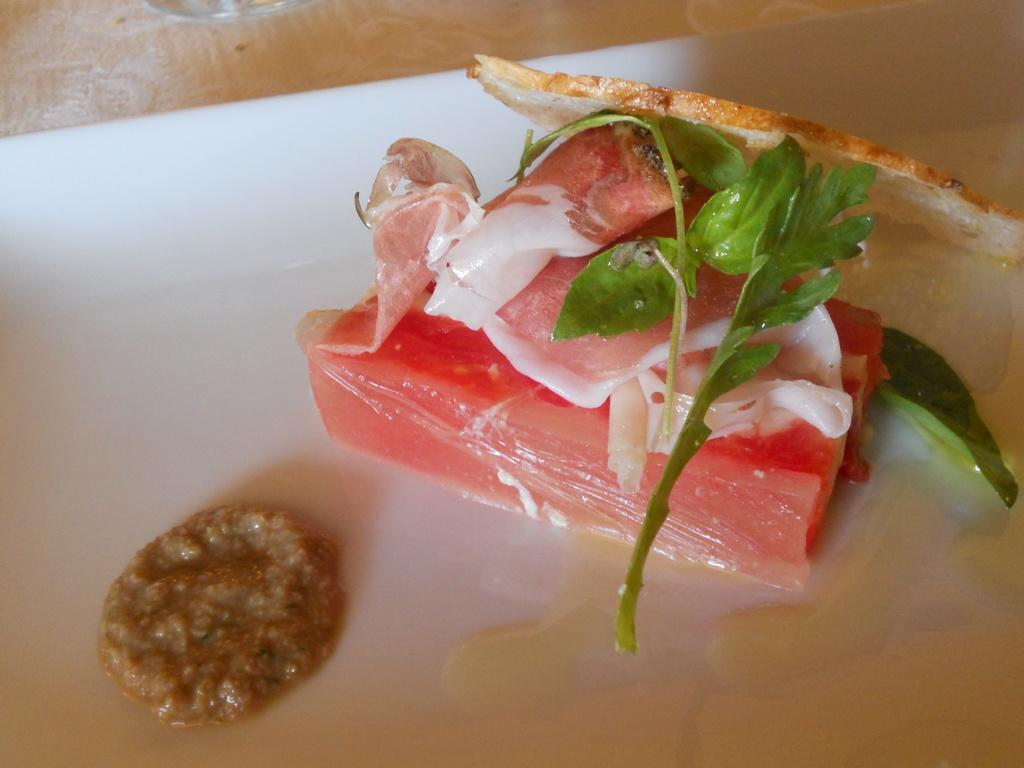What type of items can be seen in the image? There are food items in the image. How are the food items arranged or presented? The food items are on a white plate. What is the color of the plate? The plate is white. Is there any other object supporting the plate in the image? Yes, the plate is on an object. What day of the week is depicted in the image? There is no indication of a specific day of the week in the image. What type of board is visible in the image? There is no board present in the image. 